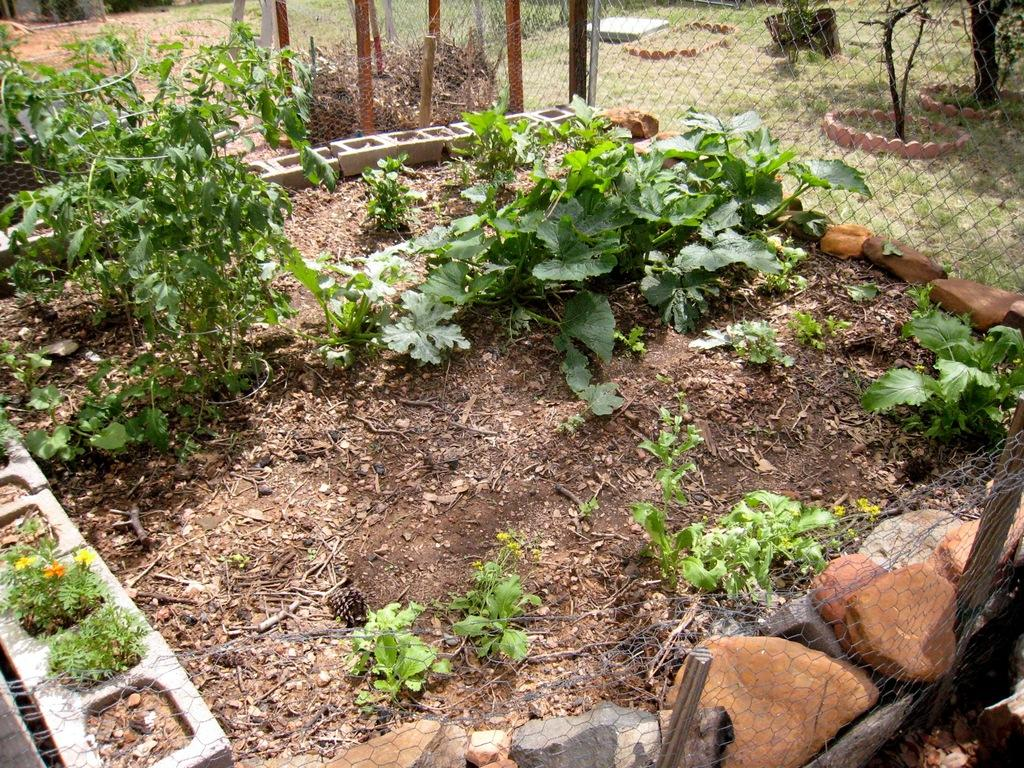What types of plants can be seen in the image? There are different kinds of plants in pots and on the ground in the image. What else is present in the image besides plants? Stones and fences are visible in the image. What type of vegetation is present in the image? Grass is present in the image. What type of shoes can be seen on the pigs in the image? There are no pigs or shoes present in the image. 